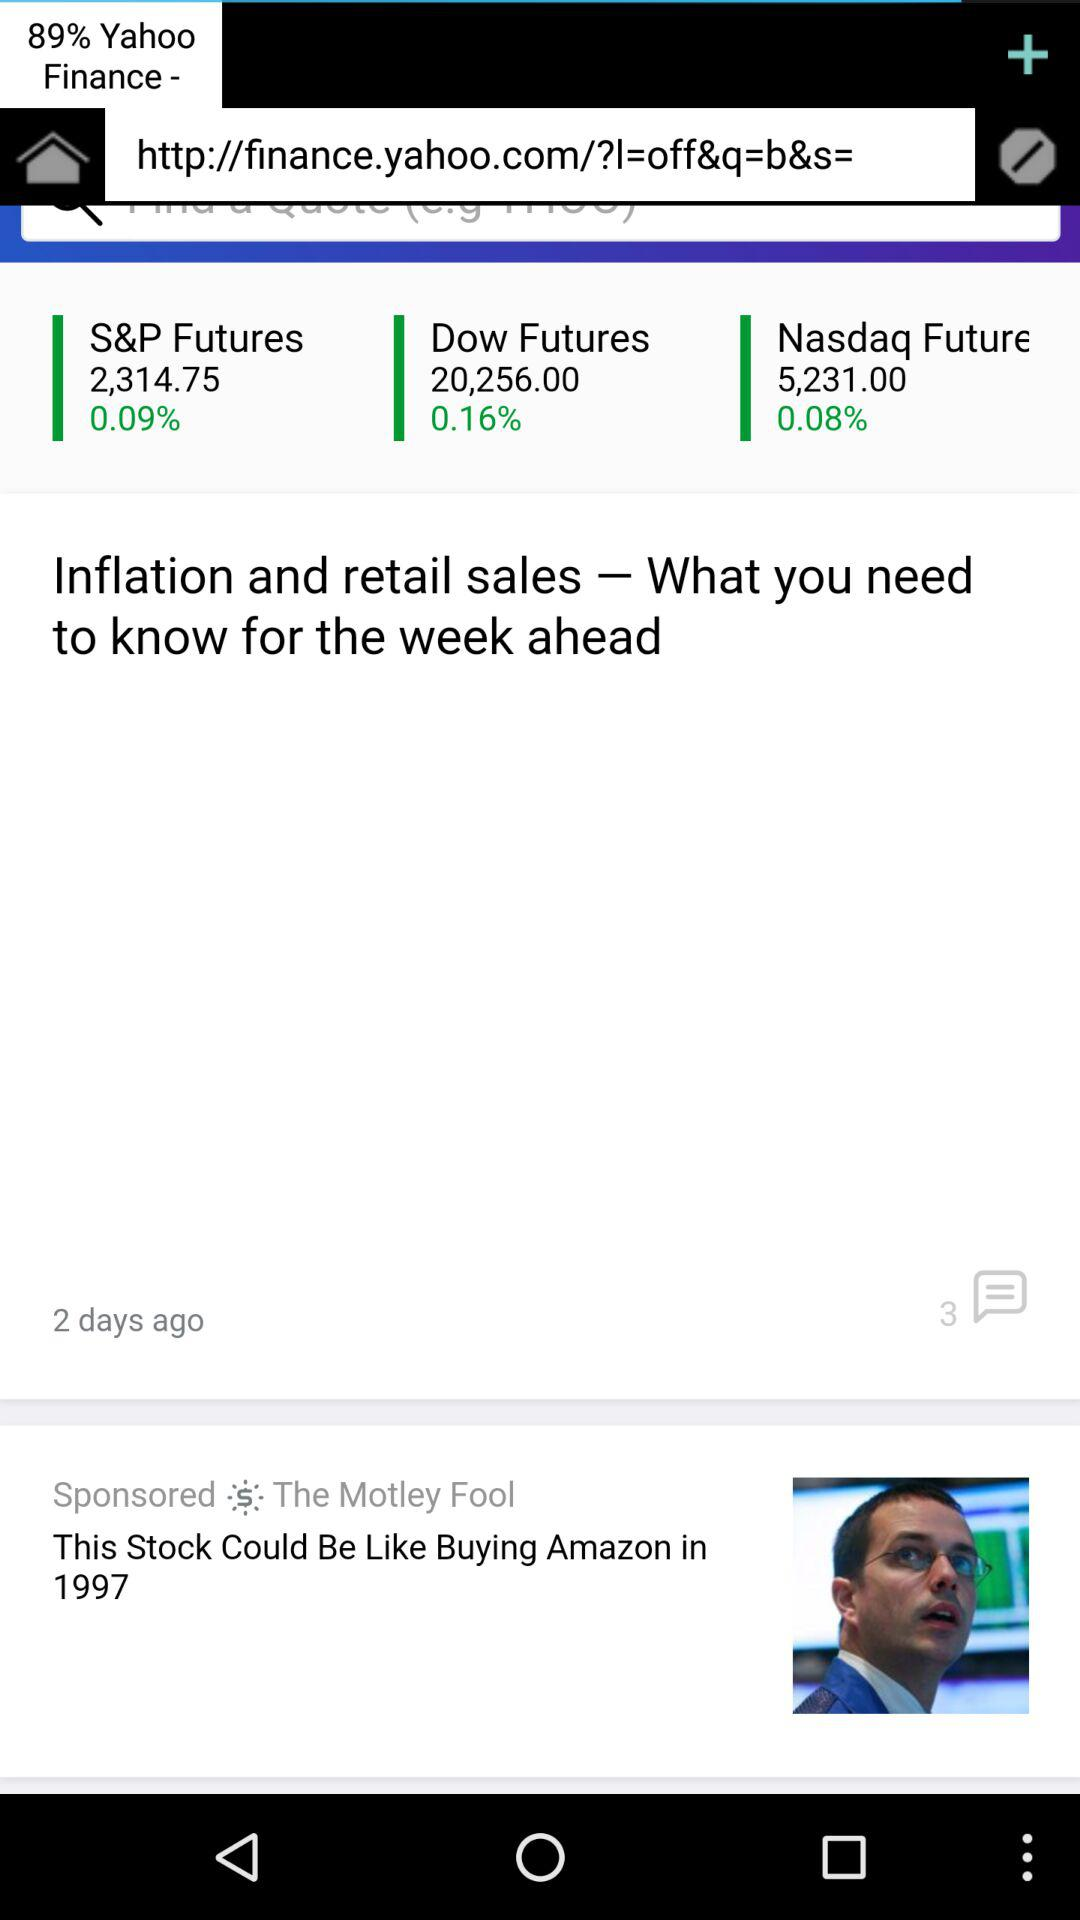How many comments were posted on the article "Inflation and retail sales - What you need to know for the week ahead"? There were 3 comments. 